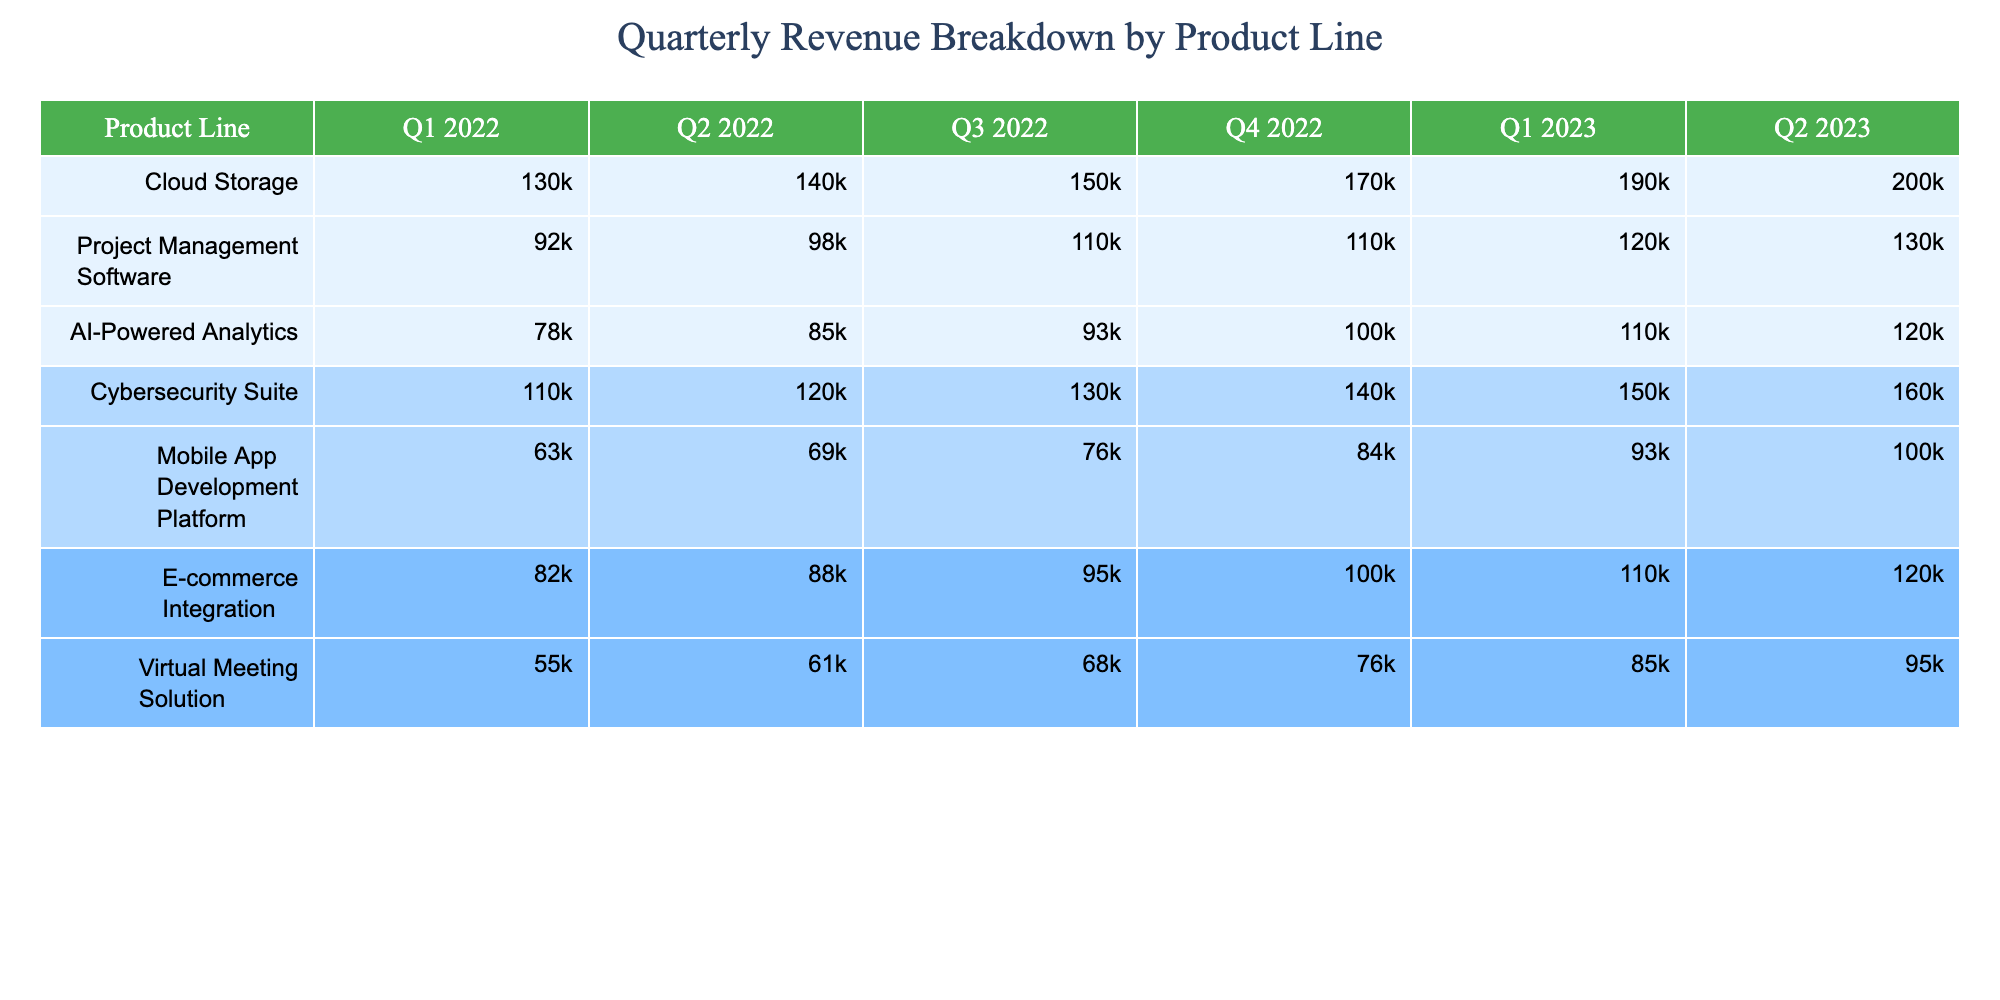What was the revenue from Cloud Storage in Q1 2023? The table shows the revenue for Cloud Storage in Q1 2023 as 185,000.
Answer: 185,000 Which product line had the highest revenue in Q4 2022? By examining the Q4 2022 column, Cybersecurity Suite has the highest revenue at 137,000.
Answer: Cybersecurity Suite What is the total revenue from Mobile App Development Platform over Q1 2022 to Q2 2023? We need to sum the values from Q1 2022 to Q2 2023: 63,000 + 69,000 + 76,000 + 84,000 + 93,000 + 103,000 = 488,000.
Answer: 488,000 Did AI-Powered Analytics generate more revenue in Q3 2022 than Project Management Software in Q2 2022? In Q3 2022, AI-Powered Analytics had 93,000, and in Q2 2022, Project Management Software had 98,000. Since 93,000 < 98,000, the statement is false.
Answer: No What is the average revenue across all product lines in Q1 2022? First, we add all the revenues for Q1 2022: 125,000 + 92,000 + 78,000 + 110,000 + 63,000 + 82,000 + 55,000 = 605,000. Then, we divide by the number of product lines (7) to get the average: 605,000 / 7 = 86,428.57.
Answer: 86,428.57 Which product line saw the largest percentage increase from Q1 2022 to Q1 2023? Calculate the percentage increase for each product line: for Cloud Storage: ((185,000 - 125,000) / 125,000) * 100 = 48%. For Project Management Software: ((120,000 - 92,000) / 92,000) * 100 = 30.43%. For AI-Powered Analytics: ((112,000 - 78,000) / 78,000) * 100 = 43.59%. For Cybersecurity Suite: ((148,000 - 110,000) / 110,000) * 100 = 34.55%. For Mobile App Development Platform: ((93,000 - 63,000) / 63,000) * 100 = 47.62%. For E-commerce Integration: ((112,000 - 82,000) / 82,000) * 100 = 36.59%. For Virtual Meeting Solution: ((85000 - 55000) / 55000) * 100 = 54.55%. The largest increase is for Virtual Meeting Solution at 54.55%.
Answer: Virtual Meeting Solution In which quarter was the revenue from Cybersecurity Suite greater than 150,000? From the table, Cybersecurity Suite reached 148,000 in Q1 2023 and 160,000 in Q2 2023, indicating that it first exceeded 150,000 in Q2 2023.
Answer: Q2 2023 What is the difference in revenue between E-commerce Integration and Mobile App Development Platform in Q4 2022? E-commerce Integration revenue in Q4 2022 was 103,000, and Mobile App Development Platform was 84,000. The difference is 103,000 - 84,000 = 19,000.
Answer: 19,000 Which product line had the lowest revenue in Q2 2023? In the Q2 2023 column, the lowest revenue is from Virtual Meeting Solution, which is 95,000.
Answer: Virtual Meeting Solution 